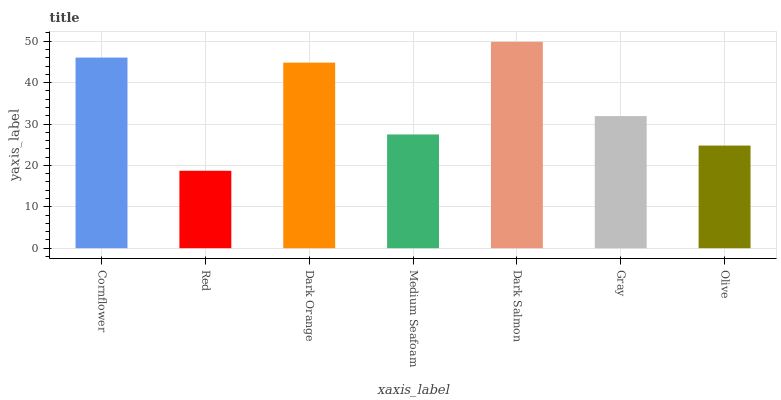Is Red the minimum?
Answer yes or no. Yes. Is Dark Salmon the maximum?
Answer yes or no. Yes. Is Dark Orange the minimum?
Answer yes or no. No. Is Dark Orange the maximum?
Answer yes or no. No. Is Dark Orange greater than Red?
Answer yes or no. Yes. Is Red less than Dark Orange?
Answer yes or no. Yes. Is Red greater than Dark Orange?
Answer yes or no. No. Is Dark Orange less than Red?
Answer yes or no. No. Is Gray the high median?
Answer yes or no. Yes. Is Gray the low median?
Answer yes or no. Yes. Is Olive the high median?
Answer yes or no. No. Is Olive the low median?
Answer yes or no. No. 